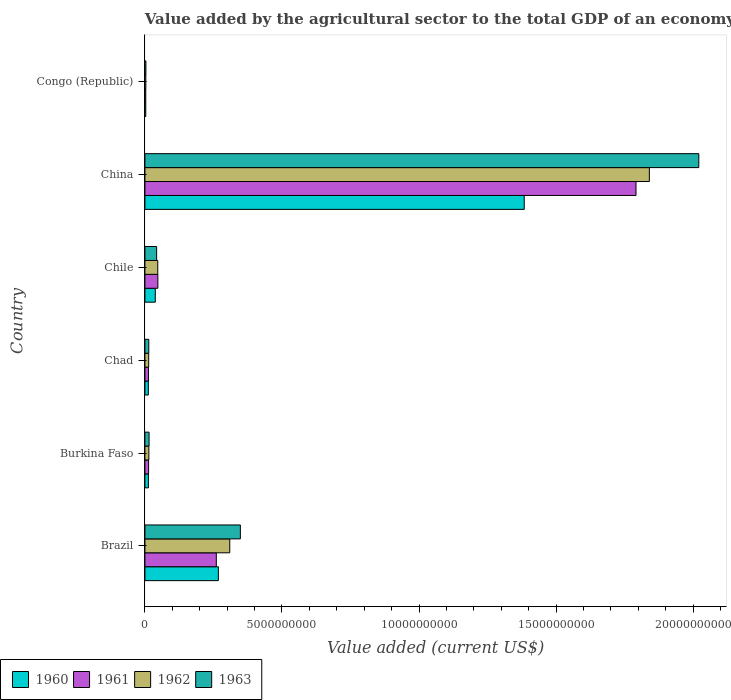Are the number of bars per tick equal to the number of legend labels?
Offer a terse response. Yes. Are the number of bars on each tick of the Y-axis equal?
Your answer should be very brief. Yes. How many bars are there on the 2nd tick from the bottom?
Ensure brevity in your answer.  4. What is the label of the 1st group of bars from the top?
Offer a terse response. Congo (Republic). What is the value added by the agricultural sector to the total GDP in 1962 in Brazil?
Your answer should be very brief. 3.10e+09. Across all countries, what is the maximum value added by the agricultural sector to the total GDP in 1960?
Offer a very short reply. 1.38e+1. Across all countries, what is the minimum value added by the agricultural sector to the total GDP in 1962?
Offer a terse response. 3.30e+07. In which country was the value added by the agricultural sector to the total GDP in 1961 minimum?
Your response must be concise. Congo (Republic). What is the total value added by the agricultural sector to the total GDP in 1962 in the graph?
Offer a very short reply. 2.23e+1. What is the difference between the value added by the agricultural sector to the total GDP in 1962 in Burkina Faso and that in Chile?
Give a very brief answer. -3.25e+08. What is the difference between the value added by the agricultural sector to the total GDP in 1962 in Congo (Republic) and the value added by the agricultural sector to the total GDP in 1963 in China?
Ensure brevity in your answer.  -2.02e+1. What is the average value added by the agricultural sector to the total GDP in 1963 per country?
Your answer should be compact. 4.07e+09. What is the difference between the value added by the agricultural sector to the total GDP in 1960 and value added by the agricultural sector to the total GDP in 1961 in Burkina Faso?
Offer a very short reply. -7.00e+06. In how many countries, is the value added by the agricultural sector to the total GDP in 1960 greater than 13000000000 US$?
Make the answer very short. 1. What is the ratio of the value added by the agricultural sector to the total GDP in 1960 in Burkina Faso to that in Chile?
Your response must be concise. 0.34. Is the value added by the agricultural sector to the total GDP in 1962 in Chad less than that in China?
Provide a short and direct response. Yes. What is the difference between the highest and the second highest value added by the agricultural sector to the total GDP in 1963?
Your answer should be very brief. 1.67e+1. What is the difference between the highest and the lowest value added by the agricultural sector to the total GDP in 1960?
Offer a very short reply. 1.38e+1. In how many countries, is the value added by the agricultural sector to the total GDP in 1963 greater than the average value added by the agricultural sector to the total GDP in 1963 taken over all countries?
Keep it short and to the point. 1. Is it the case that in every country, the sum of the value added by the agricultural sector to the total GDP in 1962 and value added by the agricultural sector to the total GDP in 1961 is greater than the sum of value added by the agricultural sector to the total GDP in 1960 and value added by the agricultural sector to the total GDP in 1963?
Your answer should be compact. No. What does the 1st bar from the bottom in Brazil represents?
Ensure brevity in your answer.  1960. What is the difference between two consecutive major ticks on the X-axis?
Your response must be concise. 5.00e+09. Are the values on the major ticks of X-axis written in scientific E-notation?
Ensure brevity in your answer.  No. Does the graph contain grids?
Your answer should be compact. No. Where does the legend appear in the graph?
Keep it short and to the point. Bottom left. What is the title of the graph?
Provide a succinct answer. Value added by the agricultural sector to the total GDP of an economy. Does "2000" appear as one of the legend labels in the graph?
Provide a succinct answer. No. What is the label or title of the X-axis?
Your answer should be very brief. Value added (current US$). What is the Value added (current US$) of 1960 in Brazil?
Ensure brevity in your answer.  2.68e+09. What is the Value added (current US$) of 1961 in Brazil?
Your answer should be compact. 2.60e+09. What is the Value added (current US$) of 1962 in Brazil?
Provide a succinct answer. 3.10e+09. What is the Value added (current US$) in 1963 in Brazil?
Provide a succinct answer. 3.48e+09. What is the Value added (current US$) in 1960 in Burkina Faso?
Provide a succinct answer. 1.27e+08. What is the Value added (current US$) of 1961 in Burkina Faso?
Make the answer very short. 1.34e+08. What is the Value added (current US$) in 1962 in Burkina Faso?
Make the answer very short. 1.44e+08. What is the Value added (current US$) in 1963 in Burkina Faso?
Provide a short and direct response. 1.52e+08. What is the Value added (current US$) in 1960 in Chad?
Offer a terse response. 1.25e+08. What is the Value added (current US$) in 1961 in Chad?
Give a very brief answer. 1.29e+08. What is the Value added (current US$) of 1962 in Chad?
Provide a succinct answer. 1.38e+08. What is the Value added (current US$) in 1963 in Chad?
Your response must be concise. 1.41e+08. What is the Value added (current US$) in 1960 in Chile?
Keep it short and to the point. 3.78e+08. What is the Value added (current US$) in 1961 in Chile?
Ensure brevity in your answer.  4.72e+08. What is the Value added (current US$) of 1962 in Chile?
Provide a succinct answer. 4.69e+08. What is the Value added (current US$) in 1963 in Chile?
Your answer should be very brief. 4.28e+08. What is the Value added (current US$) in 1960 in China?
Provide a short and direct response. 1.38e+1. What is the Value added (current US$) of 1961 in China?
Offer a very short reply. 1.79e+1. What is the Value added (current US$) in 1962 in China?
Ensure brevity in your answer.  1.84e+1. What is the Value added (current US$) of 1963 in China?
Your response must be concise. 2.02e+1. What is the Value added (current US$) of 1960 in Congo (Republic)?
Keep it short and to the point. 3.11e+07. What is the Value added (current US$) in 1961 in Congo (Republic)?
Offer a very short reply. 3.11e+07. What is the Value added (current US$) in 1962 in Congo (Republic)?
Provide a short and direct response. 3.30e+07. What is the Value added (current US$) of 1963 in Congo (Republic)?
Ensure brevity in your answer.  3.61e+07. Across all countries, what is the maximum Value added (current US$) of 1960?
Provide a succinct answer. 1.38e+1. Across all countries, what is the maximum Value added (current US$) of 1961?
Offer a terse response. 1.79e+1. Across all countries, what is the maximum Value added (current US$) of 1962?
Keep it short and to the point. 1.84e+1. Across all countries, what is the maximum Value added (current US$) of 1963?
Your answer should be very brief. 2.02e+1. Across all countries, what is the minimum Value added (current US$) of 1960?
Give a very brief answer. 3.11e+07. Across all countries, what is the minimum Value added (current US$) of 1961?
Ensure brevity in your answer.  3.11e+07. Across all countries, what is the minimum Value added (current US$) in 1962?
Provide a short and direct response. 3.30e+07. Across all countries, what is the minimum Value added (current US$) in 1963?
Make the answer very short. 3.61e+07. What is the total Value added (current US$) of 1960 in the graph?
Offer a very short reply. 1.72e+1. What is the total Value added (current US$) in 1961 in the graph?
Make the answer very short. 2.13e+1. What is the total Value added (current US$) in 1962 in the graph?
Your response must be concise. 2.23e+1. What is the total Value added (current US$) in 1963 in the graph?
Offer a terse response. 2.44e+1. What is the difference between the Value added (current US$) in 1960 in Brazil and that in Burkina Faso?
Ensure brevity in your answer.  2.55e+09. What is the difference between the Value added (current US$) of 1961 in Brazil and that in Burkina Faso?
Your answer should be very brief. 2.47e+09. What is the difference between the Value added (current US$) in 1962 in Brazil and that in Burkina Faso?
Your answer should be very brief. 2.95e+09. What is the difference between the Value added (current US$) in 1963 in Brazil and that in Burkina Faso?
Your answer should be compact. 3.33e+09. What is the difference between the Value added (current US$) of 1960 in Brazil and that in Chad?
Provide a succinct answer. 2.55e+09. What is the difference between the Value added (current US$) in 1961 in Brazil and that in Chad?
Provide a short and direct response. 2.48e+09. What is the difference between the Value added (current US$) in 1962 in Brazil and that in Chad?
Your response must be concise. 2.96e+09. What is the difference between the Value added (current US$) of 1963 in Brazil and that in Chad?
Provide a succinct answer. 3.34e+09. What is the difference between the Value added (current US$) of 1960 in Brazil and that in Chile?
Provide a succinct answer. 2.30e+09. What is the difference between the Value added (current US$) of 1961 in Brazil and that in Chile?
Make the answer very short. 2.13e+09. What is the difference between the Value added (current US$) of 1962 in Brazil and that in Chile?
Your answer should be compact. 2.63e+09. What is the difference between the Value added (current US$) of 1963 in Brazil and that in Chile?
Provide a succinct answer. 3.05e+09. What is the difference between the Value added (current US$) of 1960 in Brazil and that in China?
Provide a short and direct response. -1.12e+1. What is the difference between the Value added (current US$) of 1961 in Brazil and that in China?
Your response must be concise. -1.53e+1. What is the difference between the Value added (current US$) in 1962 in Brazil and that in China?
Provide a short and direct response. -1.53e+1. What is the difference between the Value added (current US$) of 1963 in Brazil and that in China?
Ensure brevity in your answer.  -1.67e+1. What is the difference between the Value added (current US$) of 1960 in Brazil and that in Congo (Republic)?
Give a very brief answer. 2.65e+09. What is the difference between the Value added (current US$) in 1961 in Brazil and that in Congo (Republic)?
Your answer should be very brief. 2.57e+09. What is the difference between the Value added (current US$) of 1962 in Brazil and that in Congo (Republic)?
Give a very brief answer. 3.06e+09. What is the difference between the Value added (current US$) in 1963 in Brazil and that in Congo (Republic)?
Keep it short and to the point. 3.45e+09. What is the difference between the Value added (current US$) in 1960 in Burkina Faso and that in Chad?
Your answer should be very brief. 2.61e+06. What is the difference between the Value added (current US$) in 1961 in Burkina Faso and that in Chad?
Your response must be concise. 4.79e+06. What is the difference between the Value added (current US$) of 1962 in Burkina Faso and that in Chad?
Give a very brief answer. 6.10e+06. What is the difference between the Value added (current US$) in 1963 in Burkina Faso and that in Chad?
Keep it short and to the point. 1.03e+07. What is the difference between the Value added (current US$) of 1960 in Burkina Faso and that in Chile?
Your answer should be compact. -2.51e+08. What is the difference between the Value added (current US$) in 1961 in Burkina Faso and that in Chile?
Provide a short and direct response. -3.38e+08. What is the difference between the Value added (current US$) of 1962 in Burkina Faso and that in Chile?
Make the answer very short. -3.25e+08. What is the difference between the Value added (current US$) of 1963 in Burkina Faso and that in Chile?
Give a very brief answer. -2.76e+08. What is the difference between the Value added (current US$) of 1960 in Burkina Faso and that in China?
Offer a very short reply. -1.37e+1. What is the difference between the Value added (current US$) of 1961 in Burkina Faso and that in China?
Provide a succinct answer. -1.78e+1. What is the difference between the Value added (current US$) of 1962 in Burkina Faso and that in China?
Your answer should be compact. -1.83e+1. What is the difference between the Value added (current US$) of 1963 in Burkina Faso and that in China?
Your response must be concise. -2.01e+1. What is the difference between the Value added (current US$) of 1960 in Burkina Faso and that in Congo (Republic)?
Make the answer very short. 9.61e+07. What is the difference between the Value added (current US$) in 1961 in Burkina Faso and that in Congo (Republic)?
Offer a very short reply. 1.03e+08. What is the difference between the Value added (current US$) of 1962 in Burkina Faso and that in Congo (Republic)?
Give a very brief answer. 1.11e+08. What is the difference between the Value added (current US$) of 1963 in Burkina Faso and that in Congo (Republic)?
Offer a terse response. 1.16e+08. What is the difference between the Value added (current US$) of 1960 in Chad and that in Chile?
Your response must be concise. -2.54e+08. What is the difference between the Value added (current US$) of 1961 in Chad and that in Chile?
Your answer should be compact. -3.43e+08. What is the difference between the Value added (current US$) of 1962 in Chad and that in Chile?
Your answer should be very brief. -3.31e+08. What is the difference between the Value added (current US$) in 1963 in Chad and that in Chile?
Provide a succinct answer. -2.87e+08. What is the difference between the Value added (current US$) of 1960 in Chad and that in China?
Make the answer very short. -1.37e+1. What is the difference between the Value added (current US$) of 1961 in Chad and that in China?
Make the answer very short. -1.78e+1. What is the difference between the Value added (current US$) in 1962 in Chad and that in China?
Provide a short and direct response. -1.83e+1. What is the difference between the Value added (current US$) of 1963 in Chad and that in China?
Give a very brief answer. -2.01e+1. What is the difference between the Value added (current US$) in 1960 in Chad and that in Congo (Republic)?
Offer a very short reply. 9.35e+07. What is the difference between the Value added (current US$) in 1961 in Chad and that in Congo (Republic)?
Your response must be concise. 9.83e+07. What is the difference between the Value added (current US$) of 1962 in Chad and that in Congo (Republic)?
Make the answer very short. 1.05e+08. What is the difference between the Value added (current US$) of 1963 in Chad and that in Congo (Republic)?
Your answer should be very brief. 1.05e+08. What is the difference between the Value added (current US$) in 1960 in Chile and that in China?
Your answer should be very brief. -1.35e+1. What is the difference between the Value added (current US$) of 1961 in Chile and that in China?
Give a very brief answer. -1.74e+1. What is the difference between the Value added (current US$) in 1962 in Chile and that in China?
Make the answer very short. -1.79e+1. What is the difference between the Value added (current US$) of 1963 in Chile and that in China?
Keep it short and to the point. -1.98e+1. What is the difference between the Value added (current US$) in 1960 in Chile and that in Congo (Republic)?
Your answer should be very brief. 3.47e+08. What is the difference between the Value added (current US$) in 1961 in Chile and that in Congo (Republic)?
Provide a short and direct response. 4.41e+08. What is the difference between the Value added (current US$) in 1962 in Chile and that in Congo (Republic)?
Offer a very short reply. 4.36e+08. What is the difference between the Value added (current US$) of 1963 in Chile and that in Congo (Republic)?
Provide a succinct answer. 3.92e+08. What is the difference between the Value added (current US$) of 1960 in China and that in Congo (Republic)?
Your answer should be very brief. 1.38e+1. What is the difference between the Value added (current US$) of 1961 in China and that in Congo (Republic)?
Provide a succinct answer. 1.79e+1. What is the difference between the Value added (current US$) in 1962 in China and that in Congo (Republic)?
Your response must be concise. 1.84e+1. What is the difference between the Value added (current US$) in 1963 in China and that in Congo (Republic)?
Keep it short and to the point. 2.02e+1. What is the difference between the Value added (current US$) in 1960 in Brazil and the Value added (current US$) in 1961 in Burkina Faso?
Your answer should be compact. 2.55e+09. What is the difference between the Value added (current US$) of 1960 in Brazil and the Value added (current US$) of 1962 in Burkina Faso?
Your answer should be compact. 2.54e+09. What is the difference between the Value added (current US$) in 1960 in Brazil and the Value added (current US$) in 1963 in Burkina Faso?
Offer a terse response. 2.53e+09. What is the difference between the Value added (current US$) in 1961 in Brazil and the Value added (current US$) in 1962 in Burkina Faso?
Offer a terse response. 2.46e+09. What is the difference between the Value added (current US$) of 1961 in Brazil and the Value added (current US$) of 1963 in Burkina Faso?
Ensure brevity in your answer.  2.45e+09. What is the difference between the Value added (current US$) of 1962 in Brazil and the Value added (current US$) of 1963 in Burkina Faso?
Ensure brevity in your answer.  2.94e+09. What is the difference between the Value added (current US$) of 1960 in Brazil and the Value added (current US$) of 1961 in Chad?
Offer a terse response. 2.55e+09. What is the difference between the Value added (current US$) of 1960 in Brazil and the Value added (current US$) of 1962 in Chad?
Keep it short and to the point. 2.54e+09. What is the difference between the Value added (current US$) of 1960 in Brazil and the Value added (current US$) of 1963 in Chad?
Your answer should be compact. 2.54e+09. What is the difference between the Value added (current US$) of 1961 in Brazil and the Value added (current US$) of 1962 in Chad?
Ensure brevity in your answer.  2.47e+09. What is the difference between the Value added (current US$) of 1961 in Brazil and the Value added (current US$) of 1963 in Chad?
Ensure brevity in your answer.  2.46e+09. What is the difference between the Value added (current US$) in 1962 in Brazil and the Value added (current US$) in 1963 in Chad?
Provide a short and direct response. 2.95e+09. What is the difference between the Value added (current US$) of 1960 in Brazil and the Value added (current US$) of 1961 in Chile?
Your response must be concise. 2.21e+09. What is the difference between the Value added (current US$) of 1960 in Brazil and the Value added (current US$) of 1962 in Chile?
Provide a short and direct response. 2.21e+09. What is the difference between the Value added (current US$) of 1960 in Brazil and the Value added (current US$) of 1963 in Chile?
Offer a terse response. 2.25e+09. What is the difference between the Value added (current US$) of 1961 in Brazil and the Value added (current US$) of 1962 in Chile?
Your response must be concise. 2.14e+09. What is the difference between the Value added (current US$) in 1961 in Brazil and the Value added (current US$) in 1963 in Chile?
Provide a short and direct response. 2.18e+09. What is the difference between the Value added (current US$) in 1962 in Brazil and the Value added (current US$) in 1963 in Chile?
Provide a short and direct response. 2.67e+09. What is the difference between the Value added (current US$) in 1960 in Brazil and the Value added (current US$) in 1961 in China?
Provide a succinct answer. -1.52e+1. What is the difference between the Value added (current US$) of 1960 in Brazil and the Value added (current US$) of 1962 in China?
Your answer should be very brief. -1.57e+1. What is the difference between the Value added (current US$) in 1960 in Brazil and the Value added (current US$) in 1963 in China?
Keep it short and to the point. -1.75e+1. What is the difference between the Value added (current US$) of 1961 in Brazil and the Value added (current US$) of 1962 in China?
Your answer should be very brief. -1.58e+1. What is the difference between the Value added (current US$) of 1961 in Brazil and the Value added (current US$) of 1963 in China?
Your answer should be compact. -1.76e+1. What is the difference between the Value added (current US$) of 1962 in Brazil and the Value added (current US$) of 1963 in China?
Offer a terse response. -1.71e+1. What is the difference between the Value added (current US$) of 1960 in Brazil and the Value added (current US$) of 1961 in Congo (Republic)?
Give a very brief answer. 2.65e+09. What is the difference between the Value added (current US$) in 1960 in Brazil and the Value added (current US$) in 1962 in Congo (Republic)?
Your response must be concise. 2.65e+09. What is the difference between the Value added (current US$) in 1960 in Brazil and the Value added (current US$) in 1963 in Congo (Republic)?
Offer a terse response. 2.64e+09. What is the difference between the Value added (current US$) of 1961 in Brazil and the Value added (current US$) of 1962 in Congo (Republic)?
Give a very brief answer. 2.57e+09. What is the difference between the Value added (current US$) of 1961 in Brazil and the Value added (current US$) of 1963 in Congo (Republic)?
Your answer should be very brief. 2.57e+09. What is the difference between the Value added (current US$) of 1962 in Brazil and the Value added (current US$) of 1963 in Congo (Republic)?
Your answer should be very brief. 3.06e+09. What is the difference between the Value added (current US$) in 1960 in Burkina Faso and the Value added (current US$) in 1961 in Chad?
Offer a very short reply. -2.21e+06. What is the difference between the Value added (current US$) of 1960 in Burkina Faso and the Value added (current US$) of 1962 in Chad?
Give a very brief answer. -1.04e+07. What is the difference between the Value added (current US$) of 1960 in Burkina Faso and the Value added (current US$) of 1963 in Chad?
Give a very brief answer. -1.42e+07. What is the difference between the Value added (current US$) in 1961 in Burkina Faso and the Value added (current US$) in 1962 in Chad?
Offer a terse response. -3.43e+06. What is the difference between the Value added (current US$) in 1961 in Burkina Faso and the Value added (current US$) in 1963 in Chad?
Give a very brief answer. -7.20e+06. What is the difference between the Value added (current US$) in 1962 in Burkina Faso and the Value added (current US$) in 1963 in Chad?
Offer a terse response. 2.33e+06. What is the difference between the Value added (current US$) of 1960 in Burkina Faso and the Value added (current US$) of 1961 in Chile?
Your answer should be very brief. -3.45e+08. What is the difference between the Value added (current US$) in 1960 in Burkina Faso and the Value added (current US$) in 1962 in Chile?
Provide a short and direct response. -3.41e+08. What is the difference between the Value added (current US$) of 1960 in Burkina Faso and the Value added (current US$) of 1963 in Chile?
Offer a terse response. -3.01e+08. What is the difference between the Value added (current US$) in 1961 in Burkina Faso and the Value added (current US$) in 1962 in Chile?
Your answer should be very brief. -3.34e+08. What is the difference between the Value added (current US$) of 1961 in Burkina Faso and the Value added (current US$) of 1963 in Chile?
Provide a succinct answer. -2.94e+08. What is the difference between the Value added (current US$) of 1962 in Burkina Faso and the Value added (current US$) of 1963 in Chile?
Make the answer very short. -2.84e+08. What is the difference between the Value added (current US$) in 1960 in Burkina Faso and the Value added (current US$) in 1961 in China?
Your answer should be compact. -1.78e+1. What is the difference between the Value added (current US$) in 1960 in Burkina Faso and the Value added (current US$) in 1962 in China?
Your answer should be compact. -1.83e+1. What is the difference between the Value added (current US$) in 1960 in Burkina Faso and the Value added (current US$) in 1963 in China?
Keep it short and to the point. -2.01e+1. What is the difference between the Value added (current US$) in 1961 in Burkina Faso and the Value added (current US$) in 1962 in China?
Ensure brevity in your answer.  -1.83e+1. What is the difference between the Value added (current US$) in 1961 in Burkina Faso and the Value added (current US$) in 1963 in China?
Your answer should be compact. -2.01e+1. What is the difference between the Value added (current US$) in 1962 in Burkina Faso and the Value added (current US$) in 1963 in China?
Make the answer very short. -2.01e+1. What is the difference between the Value added (current US$) of 1960 in Burkina Faso and the Value added (current US$) of 1961 in Congo (Republic)?
Your response must be concise. 9.61e+07. What is the difference between the Value added (current US$) in 1960 in Burkina Faso and the Value added (current US$) in 1962 in Congo (Republic)?
Your answer should be compact. 9.42e+07. What is the difference between the Value added (current US$) of 1960 in Burkina Faso and the Value added (current US$) of 1963 in Congo (Republic)?
Keep it short and to the point. 9.11e+07. What is the difference between the Value added (current US$) of 1961 in Burkina Faso and the Value added (current US$) of 1962 in Congo (Republic)?
Provide a succinct answer. 1.01e+08. What is the difference between the Value added (current US$) in 1961 in Burkina Faso and the Value added (current US$) in 1963 in Congo (Republic)?
Give a very brief answer. 9.81e+07. What is the difference between the Value added (current US$) of 1962 in Burkina Faso and the Value added (current US$) of 1963 in Congo (Republic)?
Provide a short and direct response. 1.08e+08. What is the difference between the Value added (current US$) of 1960 in Chad and the Value added (current US$) of 1961 in Chile?
Provide a succinct answer. -3.48e+08. What is the difference between the Value added (current US$) in 1960 in Chad and the Value added (current US$) in 1962 in Chile?
Ensure brevity in your answer.  -3.44e+08. What is the difference between the Value added (current US$) of 1960 in Chad and the Value added (current US$) of 1963 in Chile?
Offer a very short reply. -3.03e+08. What is the difference between the Value added (current US$) of 1961 in Chad and the Value added (current US$) of 1962 in Chile?
Your answer should be compact. -3.39e+08. What is the difference between the Value added (current US$) in 1961 in Chad and the Value added (current US$) in 1963 in Chile?
Offer a very short reply. -2.99e+08. What is the difference between the Value added (current US$) of 1962 in Chad and the Value added (current US$) of 1963 in Chile?
Your answer should be very brief. -2.90e+08. What is the difference between the Value added (current US$) of 1960 in Chad and the Value added (current US$) of 1961 in China?
Keep it short and to the point. -1.78e+1. What is the difference between the Value added (current US$) in 1960 in Chad and the Value added (current US$) in 1962 in China?
Your answer should be compact. -1.83e+1. What is the difference between the Value added (current US$) of 1960 in Chad and the Value added (current US$) of 1963 in China?
Provide a short and direct response. -2.01e+1. What is the difference between the Value added (current US$) in 1961 in Chad and the Value added (current US$) in 1962 in China?
Provide a succinct answer. -1.83e+1. What is the difference between the Value added (current US$) of 1961 in Chad and the Value added (current US$) of 1963 in China?
Your response must be concise. -2.01e+1. What is the difference between the Value added (current US$) of 1962 in Chad and the Value added (current US$) of 1963 in China?
Make the answer very short. -2.01e+1. What is the difference between the Value added (current US$) in 1960 in Chad and the Value added (current US$) in 1961 in Congo (Republic)?
Offer a terse response. 9.35e+07. What is the difference between the Value added (current US$) in 1960 in Chad and the Value added (current US$) in 1962 in Congo (Republic)?
Provide a short and direct response. 9.16e+07. What is the difference between the Value added (current US$) of 1960 in Chad and the Value added (current US$) of 1963 in Congo (Republic)?
Keep it short and to the point. 8.85e+07. What is the difference between the Value added (current US$) of 1961 in Chad and the Value added (current US$) of 1962 in Congo (Republic)?
Make the answer very short. 9.64e+07. What is the difference between the Value added (current US$) of 1961 in Chad and the Value added (current US$) of 1963 in Congo (Republic)?
Offer a terse response. 9.33e+07. What is the difference between the Value added (current US$) of 1962 in Chad and the Value added (current US$) of 1963 in Congo (Republic)?
Your answer should be very brief. 1.02e+08. What is the difference between the Value added (current US$) in 1960 in Chile and the Value added (current US$) in 1961 in China?
Provide a succinct answer. -1.75e+1. What is the difference between the Value added (current US$) of 1960 in Chile and the Value added (current US$) of 1962 in China?
Your response must be concise. -1.80e+1. What is the difference between the Value added (current US$) of 1960 in Chile and the Value added (current US$) of 1963 in China?
Ensure brevity in your answer.  -1.98e+1. What is the difference between the Value added (current US$) in 1961 in Chile and the Value added (current US$) in 1962 in China?
Your response must be concise. -1.79e+1. What is the difference between the Value added (current US$) in 1961 in Chile and the Value added (current US$) in 1963 in China?
Your answer should be very brief. -1.97e+1. What is the difference between the Value added (current US$) of 1962 in Chile and the Value added (current US$) of 1963 in China?
Your answer should be very brief. -1.97e+1. What is the difference between the Value added (current US$) of 1960 in Chile and the Value added (current US$) of 1961 in Congo (Republic)?
Your answer should be very brief. 3.47e+08. What is the difference between the Value added (current US$) of 1960 in Chile and the Value added (current US$) of 1962 in Congo (Republic)?
Your answer should be very brief. 3.45e+08. What is the difference between the Value added (current US$) in 1960 in Chile and the Value added (current US$) in 1963 in Congo (Republic)?
Give a very brief answer. 3.42e+08. What is the difference between the Value added (current US$) of 1961 in Chile and the Value added (current US$) of 1962 in Congo (Republic)?
Provide a short and direct response. 4.39e+08. What is the difference between the Value added (current US$) in 1961 in Chile and the Value added (current US$) in 1963 in Congo (Republic)?
Give a very brief answer. 4.36e+08. What is the difference between the Value added (current US$) of 1962 in Chile and the Value added (current US$) of 1963 in Congo (Republic)?
Make the answer very short. 4.33e+08. What is the difference between the Value added (current US$) in 1960 in China and the Value added (current US$) in 1961 in Congo (Republic)?
Your answer should be very brief. 1.38e+1. What is the difference between the Value added (current US$) of 1960 in China and the Value added (current US$) of 1962 in Congo (Republic)?
Your answer should be compact. 1.38e+1. What is the difference between the Value added (current US$) in 1960 in China and the Value added (current US$) in 1963 in Congo (Republic)?
Offer a terse response. 1.38e+1. What is the difference between the Value added (current US$) of 1961 in China and the Value added (current US$) of 1962 in Congo (Republic)?
Offer a terse response. 1.79e+1. What is the difference between the Value added (current US$) of 1961 in China and the Value added (current US$) of 1963 in Congo (Republic)?
Offer a terse response. 1.79e+1. What is the difference between the Value added (current US$) in 1962 in China and the Value added (current US$) in 1963 in Congo (Republic)?
Keep it short and to the point. 1.84e+1. What is the average Value added (current US$) of 1960 per country?
Give a very brief answer. 2.86e+09. What is the average Value added (current US$) in 1961 per country?
Ensure brevity in your answer.  3.55e+09. What is the average Value added (current US$) in 1962 per country?
Make the answer very short. 3.71e+09. What is the average Value added (current US$) in 1963 per country?
Provide a short and direct response. 4.07e+09. What is the difference between the Value added (current US$) in 1960 and Value added (current US$) in 1961 in Brazil?
Give a very brief answer. 7.45e+07. What is the difference between the Value added (current US$) of 1960 and Value added (current US$) of 1962 in Brazil?
Make the answer very short. -4.16e+08. What is the difference between the Value added (current US$) of 1960 and Value added (current US$) of 1963 in Brazil?
Provide a short and direct response. -8.03e+08. What is the difference between the Value added (current US$) in 1961 and Value added (current US$) in 1962 in Brazil?
Provide a succinct answer. -4.91e+08. What is the difference between the Value added (current US$) in 1961 and Value added (current US$) in 1963 in Brazil?
Give a very brief answer. -8.77e+08. What is the difference between the Value added (current US$) in 1962 and Value added (current US$) in 1963 in Brazil?
Offer a terse response. -3.87e+08. What is the difference between the Value added (current US$) of 1960 and Value added (current US$) of 1961 in Burkina Faso?
Provide a succinct answer. -7.00e+06. What is the difference between the Value added (current US$) in 1960 and Value added (current US$) in 1962 in Burkina Faso?
Offer a terse response. -1.65e+07. What is the difference between the Value added (current US$) in 1960 and Value added (current US$) in 1963 in Burkina Faso?
Offer a very short reply. -2.45e+07. What is the difference between the Value added (current US$) of 1961 and Value added (current US$) of 1962 in Burkina Faso?
Provide a short and direct response. -9.53e+06. What is the difference between the Value added (current US$) in 1961 and Value added (current US$) in 1963 in Burkina Faso?
Provide a succinct answer. -1.75e+07. What is the difference between the Value added (current US$) in 1962 and Value added (current US$) in 1963 in Burkina Faso?
Give a very brief answer. -7.98e+06. What is the difference between the Value added (current US$) in 1960 and Value added (current US$) in 1961 in Chad?
Your answer should be compact. -4.82e+06. What is the difference between the Value added (current US$) of 1960 and Value added (current US$) of 1962 in Chad?
Offer a terse response. -1.30e+07. What is the difference between the Value added (current US$) in 1960 and Value added (current US$) in 1963 in Chad?
Make the answer very short. -1.68e+07. What is the difference between the Value added (current US$) of 1961 and Value added (current US$) of 1962 in Chad?
Make the answer very short. -8.22e+06. What is the difference between the Value added (current US$) of 1961 and Value added (current US$) of 1963 in Chad?
Keep it short and to the point. -1.20e+07. What is the difference between the Value added (current US$) in 1962 and Value added (current US$) in 1963 in Chad?
Make the answer very short. -3.78e+06. What is the difference between the Value added (current US$) in 1960 and Value added (current US$) in 1961 in Chile?
Give a very brief answer. -9.41e+07. What is the difference between the Value added (current US$) in 1960 and Value added (current US$) in 1962 in Chile?
Make the answer very short. -9.05e+07. What is the difference between the Value added (current US$) in 1960 and Value added (current US$) in 1963 in Chile?
Your answer should be very brief. -4.98e+07. What is the difference between the Value added (current US$) in 1961 and Value added (current US$) in 1962 in Chile?
Keep it short and to the point. 3.57e+06. What is the difference between the Value added (current US$) in 1961 and Value added (current US$) in 1963 in Chile?
Give a very brief answer. 4.42e+07. What is the difference between the Value added (current US$) in 1962 and Value added (current US$) in 1963 in Chile?
Give a very brief answer. 4.07e+07. What is the difference between the Value added (current US$) of 1960 and Value added (current US$) of 1961 in China?
Give a very brief answer. -4.08e+09. What is the difference between the Value added (current US$) of 1960 and Value added (current US$) of 1962 in China?
Your answer should be very brief. -4.57e+09. What is the difference between the Value added (current US$) of 1960 and Value added (current US$) of 1963 in China?
Your answer should be compact. -6.37e+09. What is the difference between the Value added (current US$) of 1961 and Value added (current US$) of 1962 in China?
Your answer should be compact. -4.87e+08. What is the difference between the Value added (current US$) of 1961 and Value added (current US$) of 1963 in China?
Provide a short and direct response. -2.29e+09. What is the difference between the Value added (current US$) in 1962 and Value added (current US$) in 1963 in China?
Make the answer very short. -1.80e+09. What is the difference between the Value added (current US$) of 1960 and Value added (current US$) of 1961 in Congo (Republic)?
Give a very brief answer. 8239.47. What is the difference between the Value added (current US$) of 1960 and Value added (current US$) of 1962 in Congo (Republic)?
Give a very brief answer. -1.89e+06. What is the difference between the Value added (current US$) in 1960 and Value added (current US$) in 1963 in Congo (Republic)?
Your answer should be very brief. -5.00e+06. What is the difference between the Value added (current US$) of 1961 and Value added (current US$) of 1962 in Congo (Republic)?
Make the answer very short. -1.90e+06. What is the difference between the Value added (current US$) in 1961 and Value added (current US$) in 1963 in Congo (Republic)?
Give a very brief answer. -5.01e+06. What is the difference between the Value added (current US$) in 1962 and Value added (current US$) in 1963 in Congo (Republic)?
Make the answer very short. -3.11e+06. What is the ratio of the Value added (current US$) of 1960 in Brazil to that in Burkina Faso?
Offer a very short reply. 21.07. What is the ratio of the Value added (current US$) of 1961 in Brazil to that in Burkina Faso?
Provide a short and direct response. 19.41. What is the ratio of the Value added (current US$) of 1962 in Brazil to that in Burkina Faso?
Make the answer very short. 21.54. What is the ratio of the Value added (current US$) of 1963 in Brazil to that in Burkina Faso?
Provide a succinct answer. 22.96. What is the ratio of the Value added (current US$) in 1960 in Brazil to that in Chad?
Offer a very short reply. 21.51. What is the ratio of the Value added (current US$) of 1961 in Brazil to that in Chad?
Keep it short and to the point. 20.13. What is the ratio of the Value added (current US$) of 1962 in Brazil to that in Chad?
Keep it short and to the point. 22.5. What is the ratio of the Value added (current US$) in 1963 in Brazil to that in Chad?
Provide a short and direct response. 24.63. What is the ratio of the Value added (current US$) in 1960 in Brazil to that in Chile?
Make the answer very short. 7.09. What is the ratio of the Value added (current US$) of 1961 in Brazil to that in Chile?
Make the answer very short. 5.52. What is the ratio of the Value added (current US$) in 1962 in Brazil to that in Chile?
Make the answer very short. 6.61. What is the ratio of the Value added (current US$) in 1963 in Brazil to that in Chile?
Your response must be concise. 8.14. What is the ratio of the Value added (current US$) in 1960 in Brazil to that in China?
Your response must be concise. 0.19. What is the ratio of the Value added (current US$) in 1961 in Brazil to that in China?
Your answer should be compact. 0.15. What is the ratio of the Value added (current US$) in 1962 in Brazil to that in China?
Provide a succinct answer. 0.17. What is the ratio of the Value added (current US$) of 1963 in Brazil to that in China?
Give a very brief answer. 0.17. What is the ratio of the Value added (current US$) of 1960 in Brazil to that in Congo (Republic)?
Your response must be concise. 86.18. What is the ratio of the Value added (current US$) in 1961 in Brazil to that in Congo (Republic)?
Ensure brevity in your answer.  83.81. What is the ratio of the Value added (current US$) of 1962 in Brazil to that in Congo (Republic)?
Your answer should be very brief. 93.86. What is the ratio of the Value added (current US$) in 1963 in Brazil to that in Congo (Republic)?
Your response must be concise. 96.49. What is the ratio of the Value added (current US$) in 1961 in Burkina Faso to that in Chad?
Give a very brief answer. 1.04. What is the ratio of the Value added (current US$) in 1962 in Burkina Faso to that in Chad?
Your response must be concise. 1.04. What is the ratio of the Value added (current US$) in 1963 in Burkina Faso to that in Chad?
Offer a terse response. 1.07. What is the ratio of the Value added (current US$) of 1960 in Burkina Faso to that in Chile?
Make the answer very short. 0.34. What is the ratio of the Value added (current US$) in 1961 in Burkina Faso to that in Chile?
Keep it short and to the point. 0.28. What is the ratio of the Value added (current US$) of 1962 in Burkina Faso to that in Chile?
Provide a succinct answer. 0.31. What is the ratio of the Value added (current US$) in 1963 in Burkina Faso to that in Chile?
Your answer should be compact. 0.35. What is the ratio of the Value added (current US$) of 1960 in Burkina Faso to that in China?
Keep it short and to the point. 0.01. What is the ratio of the Value added (current US$) of 1961 in Burkina Faso to that in China?
Give a very brief answer. 0.01. What is the ratio of the Value added (current US$) of 1962 in Burkina Faso to that in China?
Give a very brief answer. 0.01. What is the ratio of the Value added (current US$) of 1963 in Burkina Faso to that in China?
Provide a succinct answer. 0.01. What is the ratio of the Value added (current US$) of 1960 in Burkina Faso to that in Congo (Republic)?
Offer a terse response. 4.09. What is the ratio of the Value added (current US$) in 1961 in Burkina Faso to that in Congo (Republic)?
Offer a terse response. 4.32. What is the ratio of the Value added (current US$) in 1962 in Burkina Faso to that in Congo (Republic)?
Your answer should be very brief. 4.36. What is the ratio of the Value added (current US$) of 1963 in Burkina Faso to that in Congo (Republic)?
Provide a succinct answer. 4.2. What is the ratio of the Value added (current US$) of 1960 in Chad to that in Chile?
Make the answer very short. 0.33. What is the ratio of the Value added (current US$) of 1961 in Chad to that in Chile?
Your answer should be compact. 0.27. What is the ratio of the Value added (current US$) in 1962 in Chad to that in Chile?
Your response must be concise. 0.29. What is the ratio of the Value added (current US$) of 1963 in Chad to that in Chile?
Keep it short and to the point. 0.33. What is the ratio of the Value added (current US$) in 1960 in Chad to that in China?
Ensure brevity in your answer.  0.01. What is the ratio of the Value added (current US$) in 1961 in Chad to that in China?
Offer a terse response. 0.01. What is the ratio of the Value added (current US$) in 1962 in Chad to that in China?
Your answer should be compact. 0.01. What is the ratio of the Value added (current US$) in 1963 in Chad to that in China?
Give a very brief answer. 0.01. What is the ratio of the Value added (current US$) in 1960 in Chad to that in Congo (Republic)?
Offer a very short reply. 4.01. What is the ratio of the Value added (current US$) in 1961 in Chad to that in Congo (Republic)?
Your response must be concise. 4.16. What is the ratio of the Value added (current US$) in 1962 in Chad to that in Congo (Republic)?
Offer a terse response. 4.17. What is the ratio of the Value added (current US$) in 1963 in Chad to that in Congo (Republic)?
Offer a very short reply. 3.92. What is the ratio of the Value added (current US$) of 1960 in Chile to that in China?
Provide a succinct answer. 0.03. What is the ratio of the Value added (current US$) of 1961 in Chile to that in China?
Your response must be concise. 0.03. What is the ratio of the Value added (current US$) in 1962 in Chile to that in China?
Offer a very short reply. 0.03. What is the ratio of the Value added (current US$) of 1963 in Chile to that in China?
Your response must be concise. 0.02. What is the ratio of the Value added (current US$) in 1960 in Chile to that in Congo (Republic)?
Make the answer very short. 12.16. What is the ratio of the Value added (current US$) in 1961 in Chile to that in Congo (Republic)?
Offer a terse response. 15.19. What is the ratio of the Value added (current US$) in 1962 in Chile to that in Congo (Republic)?
Your answer should be very brief. 14.21. What is the ratio of the Value added (current US$) of 1963 in Chile to that in Congo (Republic)?
Your answer should be compact. 11.86. What is the ratio of the Value added (current US$) in 1960 in China to that in Congo (Republic)?
Offer a terse response. 445.15. What is the ratio of the Value added (current US$) in 1961 in China to that in Congo (Republic)?
Give a very brief answer. 576.48. What is the ratio of the Value added (current US$) in 1962 in China to that in Congo (Republic)?
Offer a terse response. 558.09. What is the ratio of the Value added (current US$) of 1963 in China to that in Congo (Republic)?
Your response must be concise. 559.95. What is the difference between the highest and the second highest Value added (current US$) of 1960?
Provide a short and direct response. 1.12e+1. What is the difference between the highest and the second highest Value added (current US$) of 1961?
Give a very brief answer. 1.53e+1. What is the difference between the highest and the second highest Value added (current US$) of 1962?
Your answer should be compact. 1.53e+1. What is the difference between the highest and the second highest Value added (current US$) of 1963?
Your answer should be compact. 1.67e+1. What is the difference between the highest and the lowest Value added (current US$) of 1960?
Your answer should be compact. 1.38e+1. What is the difference between the highest and the lowest Value added (current US$) in 1961?
Offer a terse response. 1.79e+1. What is the difference between the highest and the lowest Value added (current US$) in 1962?
Ensure brevity in your answer.  1.84e+1. What is the difference between the highest and the lowest Value added (current US$) of 1963?
Keep it short and to the point. 2.02e+1. 